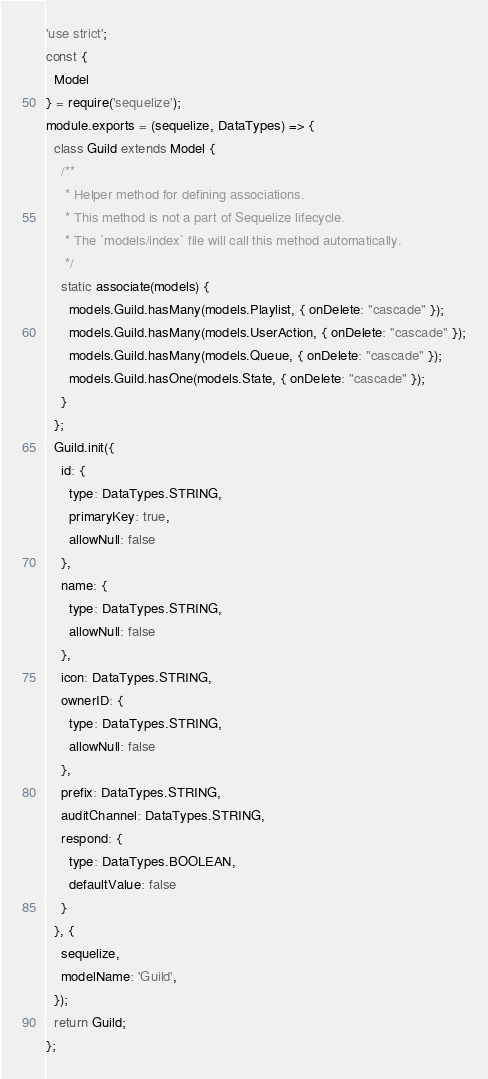<code> <loc_0><loc_0><loc_500><loc_500><_JavaScript_>'use strict';
const {
  Model
} = require('sequelize');
module.exports = (sequelize, DataTypes) => {
  class Guild extends Model {
    /**
     * Helper method for defining associations.
     * This method is not a part of Sequelize lifecycle.
     * The `models/index` file will call this method automatically.
     */
    static associate(models) {
      models.Guild.hasMany(models.Playlist, { onDelete: "cascade" });
      models.Guild.hasMany(models.UserAction, { onDelete: "cascade" });
      models.Guild.hasMany(models.Queue, { onDelete: "cascade" });
      models.Guild.hasOne(models.State, { onDelete: "cascade" });
    }
  };
  Guild.init({
    id: {
      type: DataTypes.STRING,
      primaryKey: true,
      allowNull: false
    },
    name: {
      type: DataTypes.STRING,
      allowNull: false
    },
    icon: DataTypes.STRING,
    ownerID: {
      type: DataTypes.STRING,
      allowNull: false
    },
    prefix: DataTypes.STRING,
    auditChannel: DataTypes.STRING,
    respond: {
      type: DataTypes.BOOLEAN,
      defaultValue: false
    }
  }, {
    sequelize,
    modelName: 'Guild',
  });
  return Guild;
};
</code> 